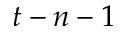Convert formula to latex. <formula><loc_0><loc_0><loc_500><loc_500>t - n - 1</formula> 